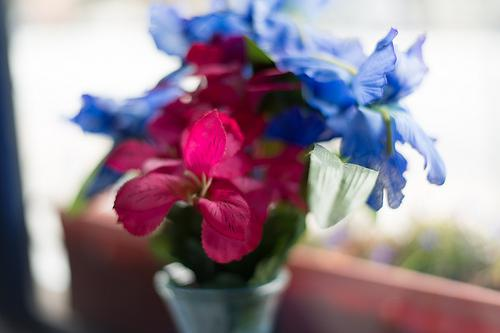Question: what kind of light is shining in the background?
Choices:
A. Moonlight.
B. Sunlight.
C. Star light.
D. Car lights.
Answer with the letter. Answer: B 